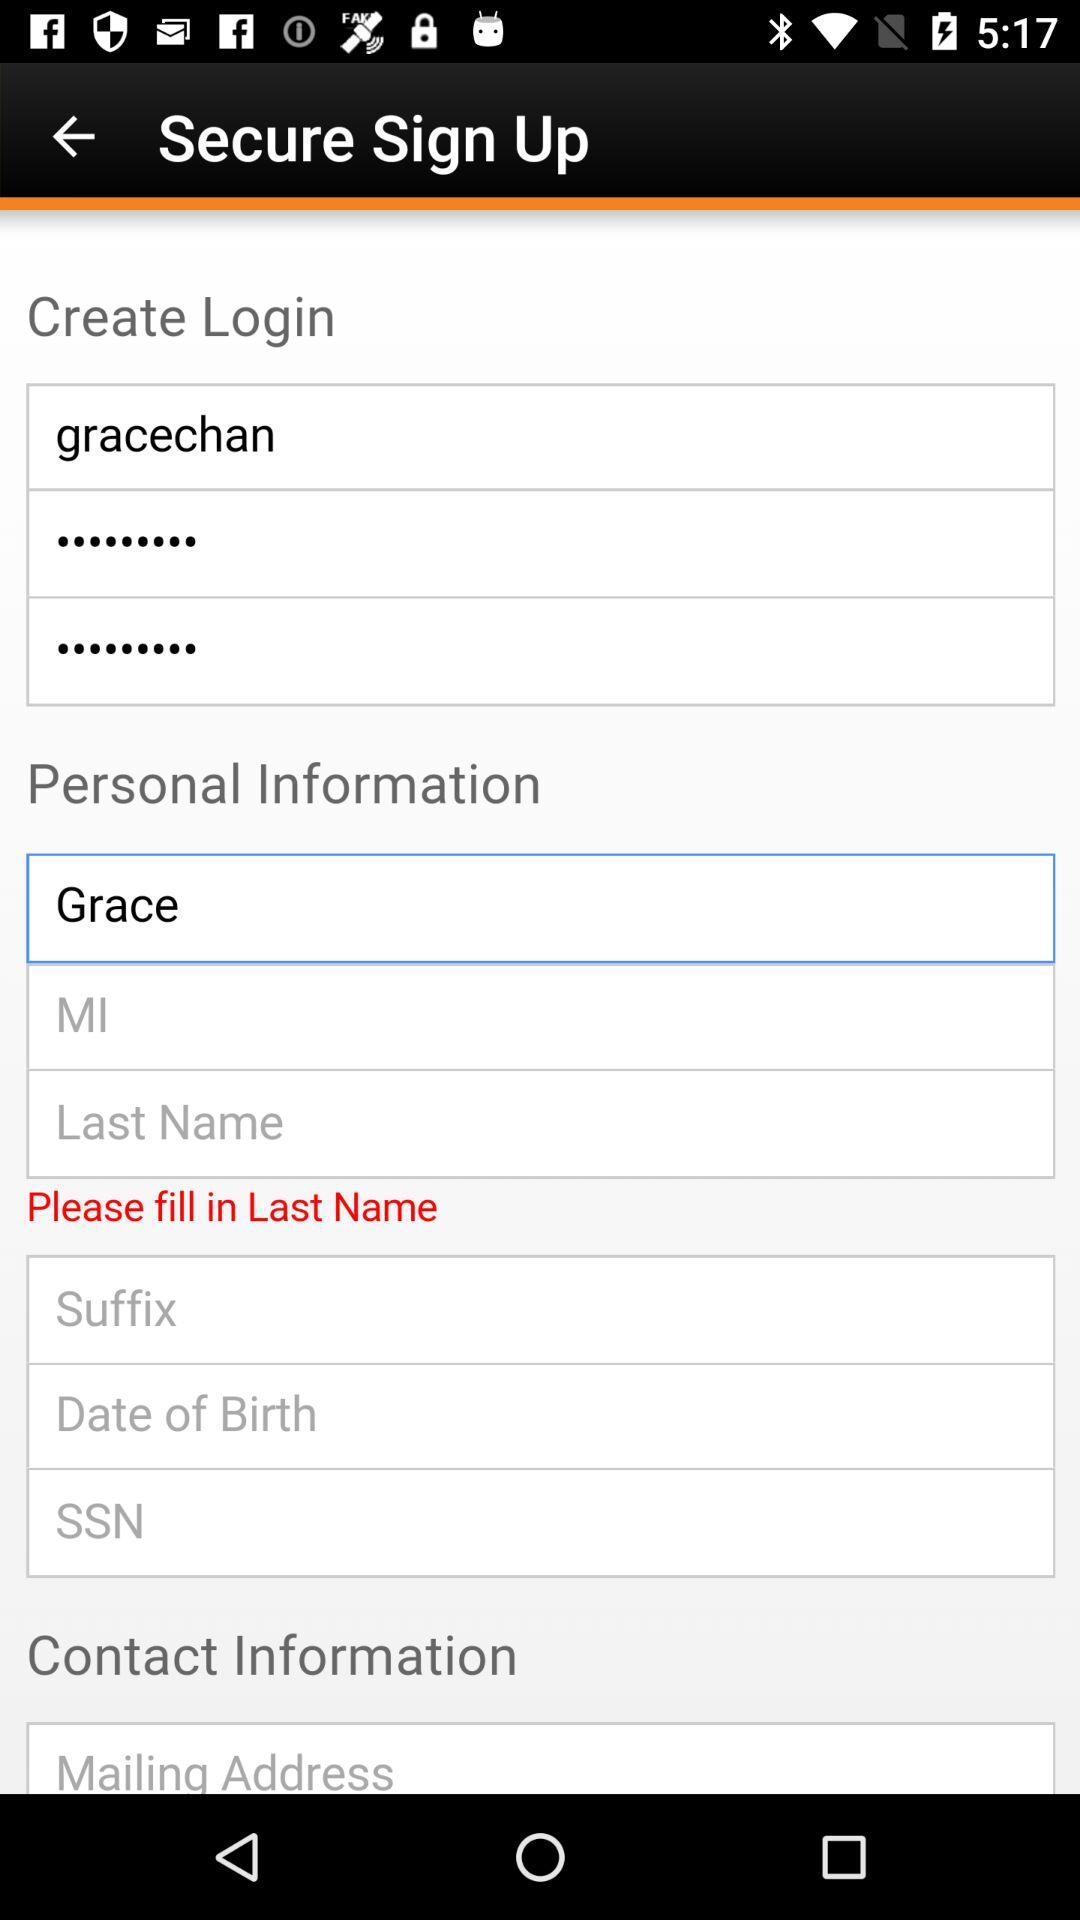What is the name of the user? The name of the user is Grace. 